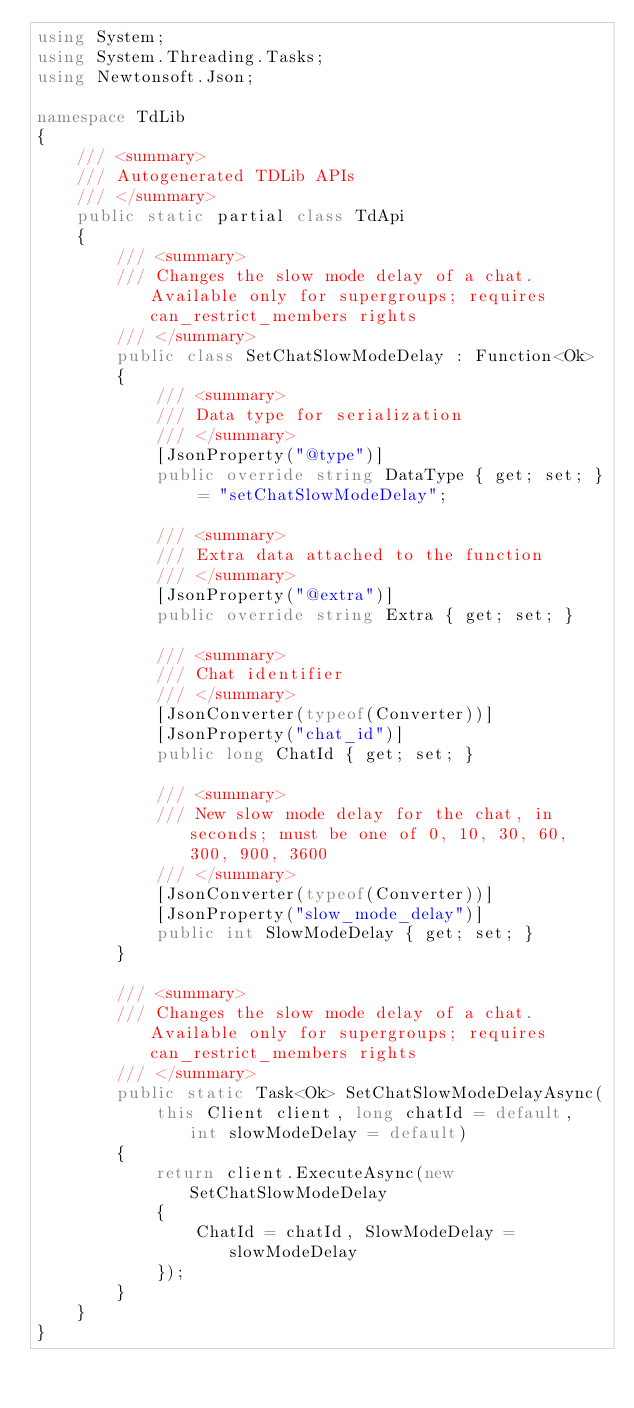<code> <loc_0><loc_0><loc_500><loc_500><_C#_>using System;
using System.Threading.Tasks;
using Newtonsoft.Json;

namespace TdLib
{
    /// <summary>
    /// Autogenerated TDLib APIs
    /// </summary>
    public static partial class TdApi
    {
        /// <summary>
        /// Changes the slow mode delay of a chat. Available only for supergroups; requires can_restrict_members rights
        /// </summary>
        public class SetChatSlowModeDelay : Function<Ok>
        {
            /// <summary>
            /// Data type for serialization
            /// </summary>
            [JsonProperty("@type")]
            public override string DataType { get; set; } = "setChatSlowModeDelay";

            /// <summary>
            /// Extra data attached to the function
            /// </summary>
            [JsonProperty("@extra")]
            public override string Extra { get; set; }

            /// <summary>
            /// Chat identifier
            /// </summary>
            [JsonConverter(typeof(Converter))]
            [JsonProperty("chat_id")]
            public long ChatId { get; set; }

            /// <summary>
            /// New slow mode delay for the chat, in seconds; must be one of 0, 10, 30, 60, 300, 900, 3600
            /// </summary>
            [JsonConverter(typeof(Converter))]
            [JsonProperty("slow_mode_delay")]
            public int SlowModeDelay { get; set; }
        }

        /// <summary>
        /// Changes the slow mode delay of a chat. Available only for supergroups; requires can_restrict_members rights
        /// </summary>
        public static Task<Ok> SetChatSlowModeDelayAsync(
            this Client client, long chatId = default, int slowModeDelay = default)
        {
            return client.ExecuteAsync(new SetChatSlowModeDelay
            {
                ChatId = chatId, SlowModeDelay = slowModeDelay
            });
        }
    }
}</code> 